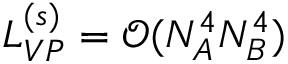<formula> <loc_0><loc_0><loc_500><loc_500>L _ { V P } ^ { ( s ) } = \mathcal { O } ( N _ { A } ^ { 4 } N _ { B } ^ { 4 } )</formula> 